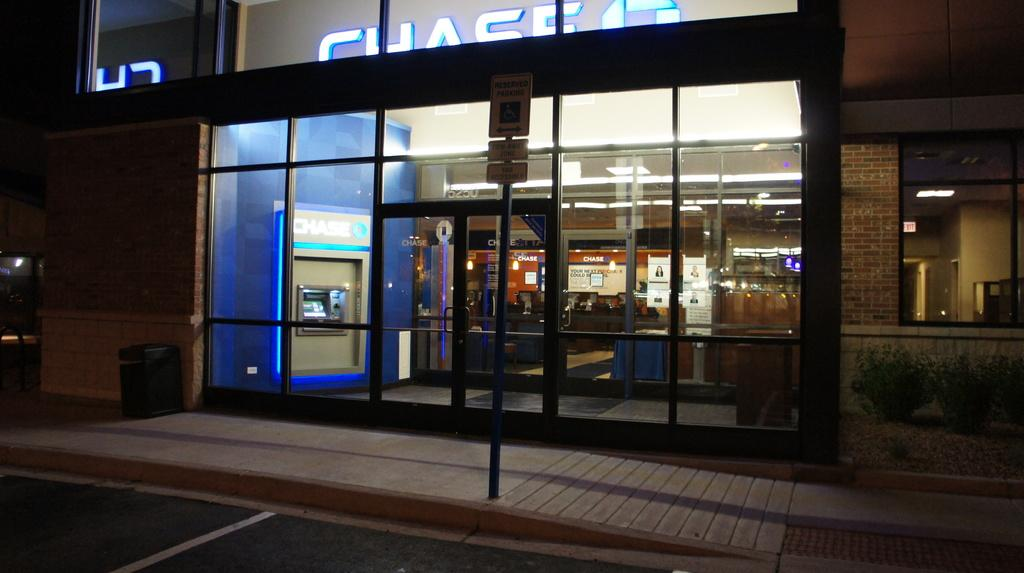Provide a one-sentence caption for the provided image. Then entrance to a building that has a Chase bank inside. 